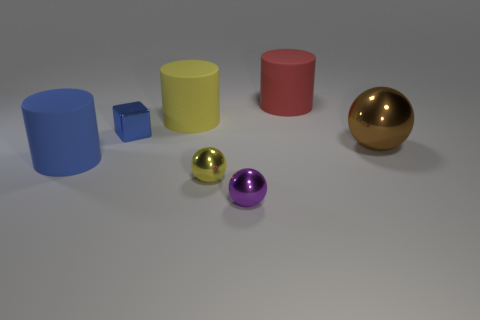Is there anything else of the same color as the big metal ball?
Ensure brevity in your answer.  No. Does the rubber object that is in front of the large yellow rubber cylinder have the same color as the tiny metallic block?
Keep it short and to the point. Yes. How many cylinders are on the right side of the large matte cylinder on the left side of the blue cube?
Ensure brevity in your answer.  2. There is a metal cube that is the same size as the yellow ball; what is its color?
Offer a terse response. Blue. What is the purple object in front of the small blue metal cube made of?
Provide a short and direct response. Metal. There is a object that is both left of the tiny yellow metal ball and in front of the big shiny object; what material is it made of?
Offer a terse response. Rubber. There is a rubber cylinder right of the yellow shiny sphere; does it have the same size as the blue metal object?
Provide a succinct answer. No. There is a large red thing; what shape is it?
Make the answer very short. Cylinder. What number of small purple things are the same shape as the yellow shiny thing?
Make the answer very short. 1. What number of things are in front of the red matte cylinder and behind the purple shiny sphere?
Your answer should be compact. 5. 